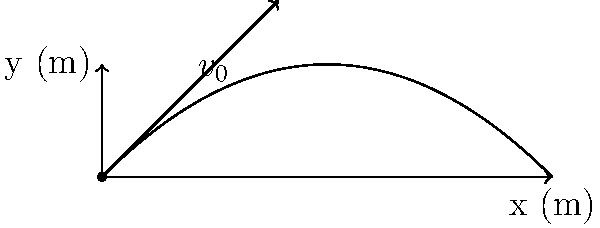During a heated PC vs Mac debate, an IT specialist impulsively throws their MacBook Air (mass 1.25 kg) with an initial velocity of 5 m/s at an angle of 45° above the horizontal. Assuming air resistance is negligible, calculate the maximum height reached by the laptop during its trajectory. To find the maximum height, we'll follow these steps:

1) The initial velocity components are:
   $v_{0x} = v_0 \cos \theta = 5 \cos 45° = 5 \cdot \frac{\sqrt{2}}{2} \approx 3.54$ m/s
   $v_{0y} = v_0 \sin \theta = 5 \sin 45° = 5 \cdot \frac{\sqrt{2}}{2} \approx 3.54$ m/s

2) The time to reach maximum height is when the vertical velocity becomes zero:
   $v_y = v_{0y} - gt = 0$
   $t = \frac{v_{0y}}{g} = \frac{3.54}{9.8} \approx 0.36$ s

3) The maximum height can be calculated using the equation:
   $y = v_{0y}t - \frac{1}{2}gt^2$

4) Substituting the values:
   $y_{max} = (3.54)(0.36) - \frac{1}{2}(9.8)(0.36)^2$
   $y_{max} = 1.27 - 0.64 = 0.63$ m

Therefore, the maximum height reached by the MacBook Air is approximately 0.63 meters.
Answer: 0.63 m 